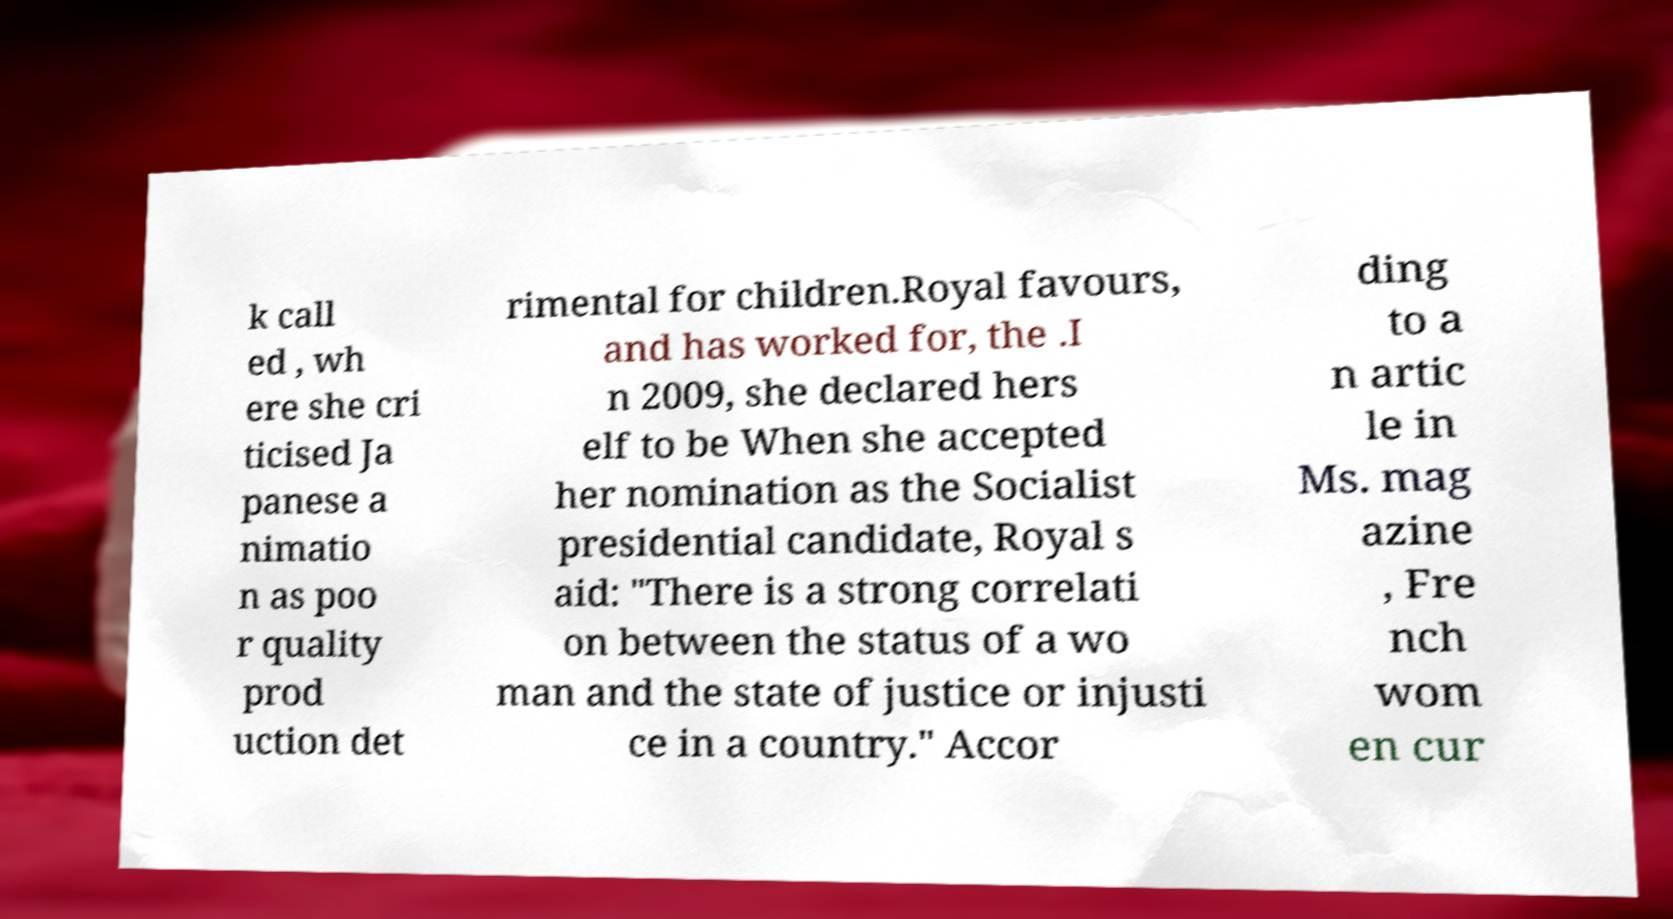Could you extract and type out the text from this image? k call ed , wh ere she cri ticised Ja panese a nimatio n as poo r quality prod uction det rimental for children.Royal favours, and has worked for, the .I n 2009, she declared hers elf to be When she accepted her nomination as the Socialist presidential candidate, Royal s aid: "There is a strong correlati on between the status of a wo man and the state of justice or injusti ce in a country." Accor ding to a n artic le in Ms. mag azine , Fre nch wom en cur 